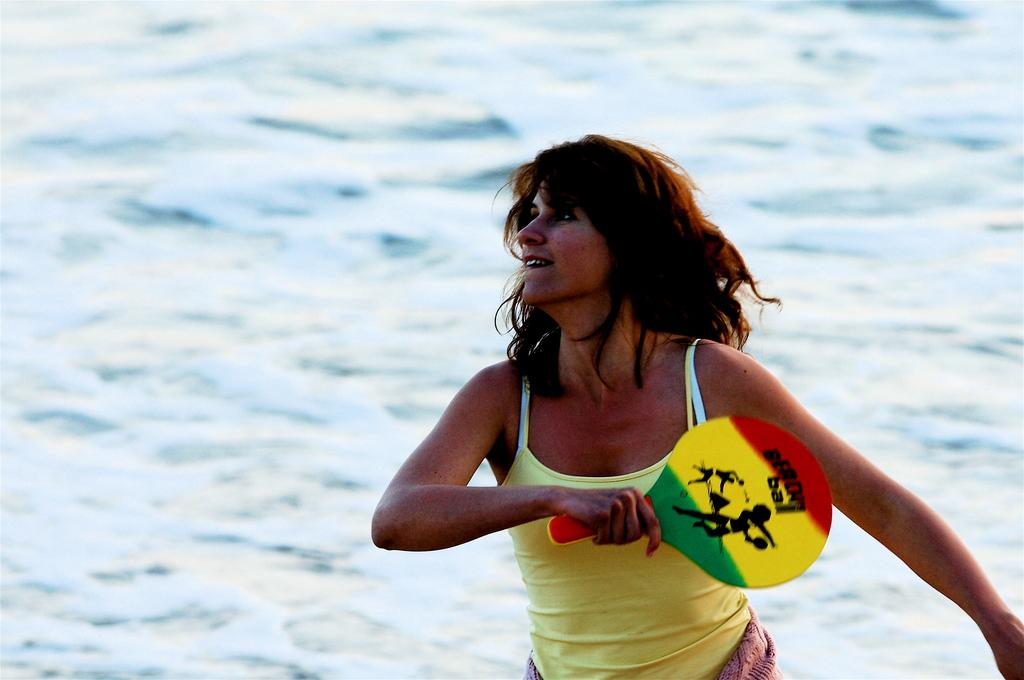Who is present in the image? There is a woman in the image. What is the woman wearing? The woman is wearing a yellow dress. What object is the woman holding? The woman is holding a racket. How many ladybugs can be seen on the woman's trousers in the image? There is no mention of ladybugs or trousers in the image, as the woman is wearing a yellow dress and there is no reference to ladybugs. 